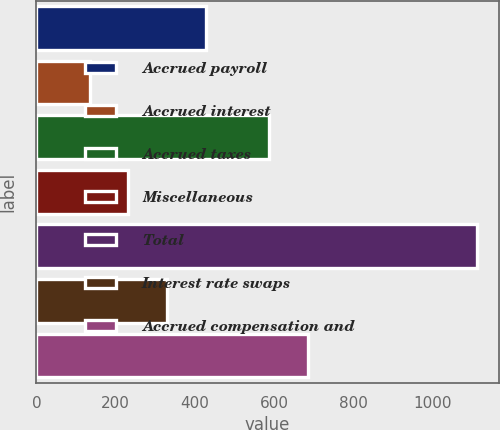Convert chart to OTSL. <chart><loc_0><loc_0><loc_500><loc_500><bar_chart><fcel>Accrued payroll<fcel>Accrued interest<fcel>Accrued taxes<fcel>Miscellaneous<fcel>Total<fcel>Interest rate swaps<fcel>Accrued compensation and<nl><fcel>427.1<fcel>134<fcel>588<fcel>231.7<fcel>1111<fcel>329.4<fcel>685.7<nl></chart> 